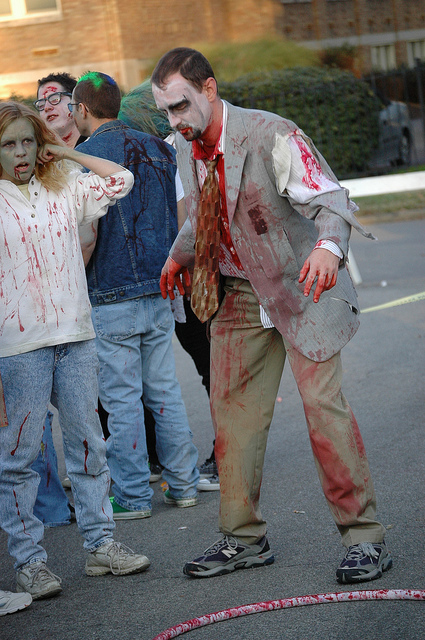What event could these individuals possibly be participating in? Based on their attire and makeup, they seem to be part of a zombie walk, which is a public gathering where people dress up as zombies and walk through an urban area as part of an event celebrating zombie culture. 